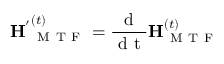<formula> <loc_0><loc_0><loc_500><loc_500>H ^ { ^ { \prime } } _ { M T F } ^ { ( t ) } = \frac { d } { d t } H _ { M T F } ^ { ( t ) }</formula> 